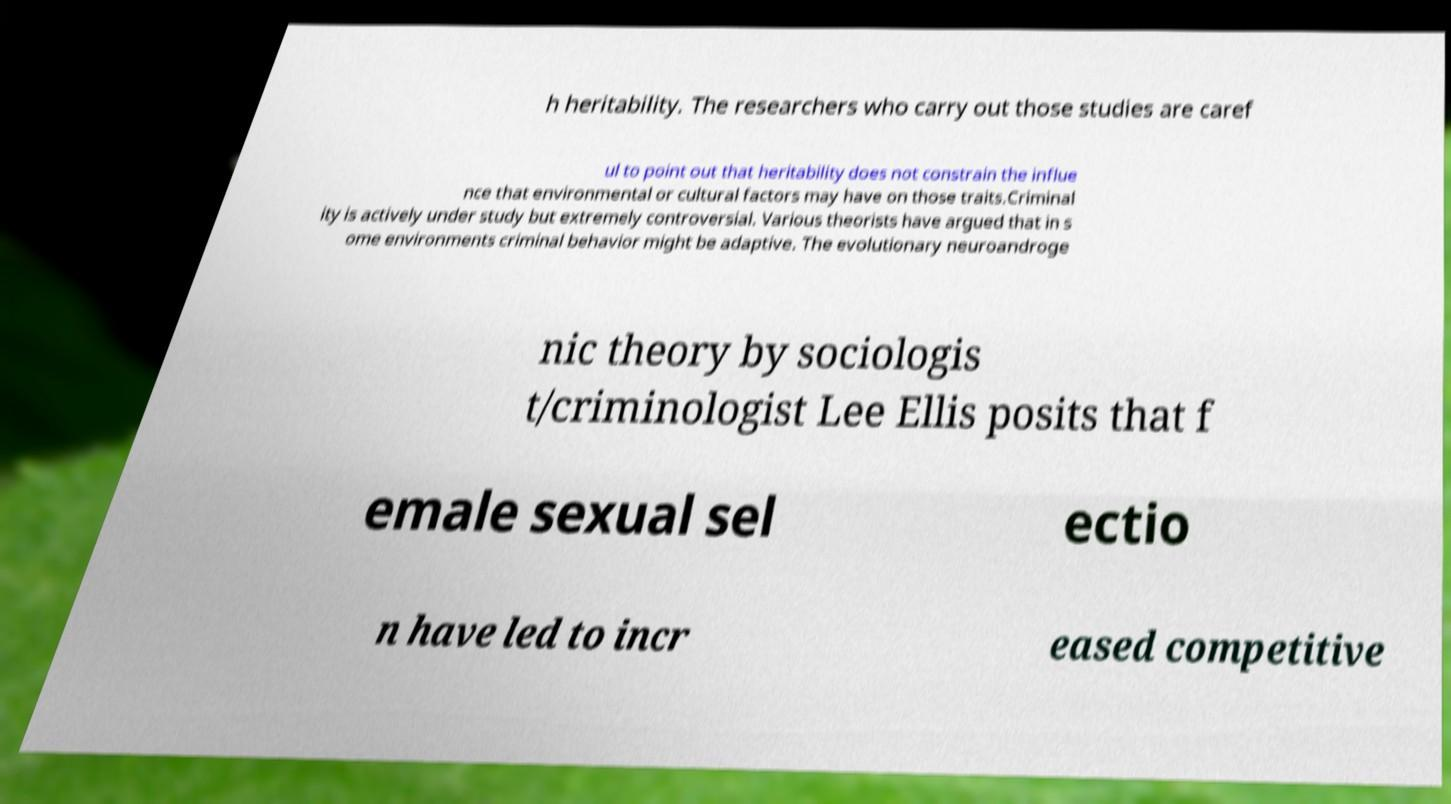Can you read and provide the text displayed in the image?This photo seems to have some interesting text. Can you extract and type it out for me? h heritability. The researchers who carry out those studies are caref ul to point out that heritability does not constrain the influe nce that environmental or cultural factors may have on those traits.Criminal ity is actively under study but extremely controversial. Various theorists have argued that in s ome environments criminal behavior might be adaptive. The evolutionary neuroandroge nic theory by sociologis t/criminologist Lee Ellis posits that f emale sexual sel ectio n have led to incr eased competitive 